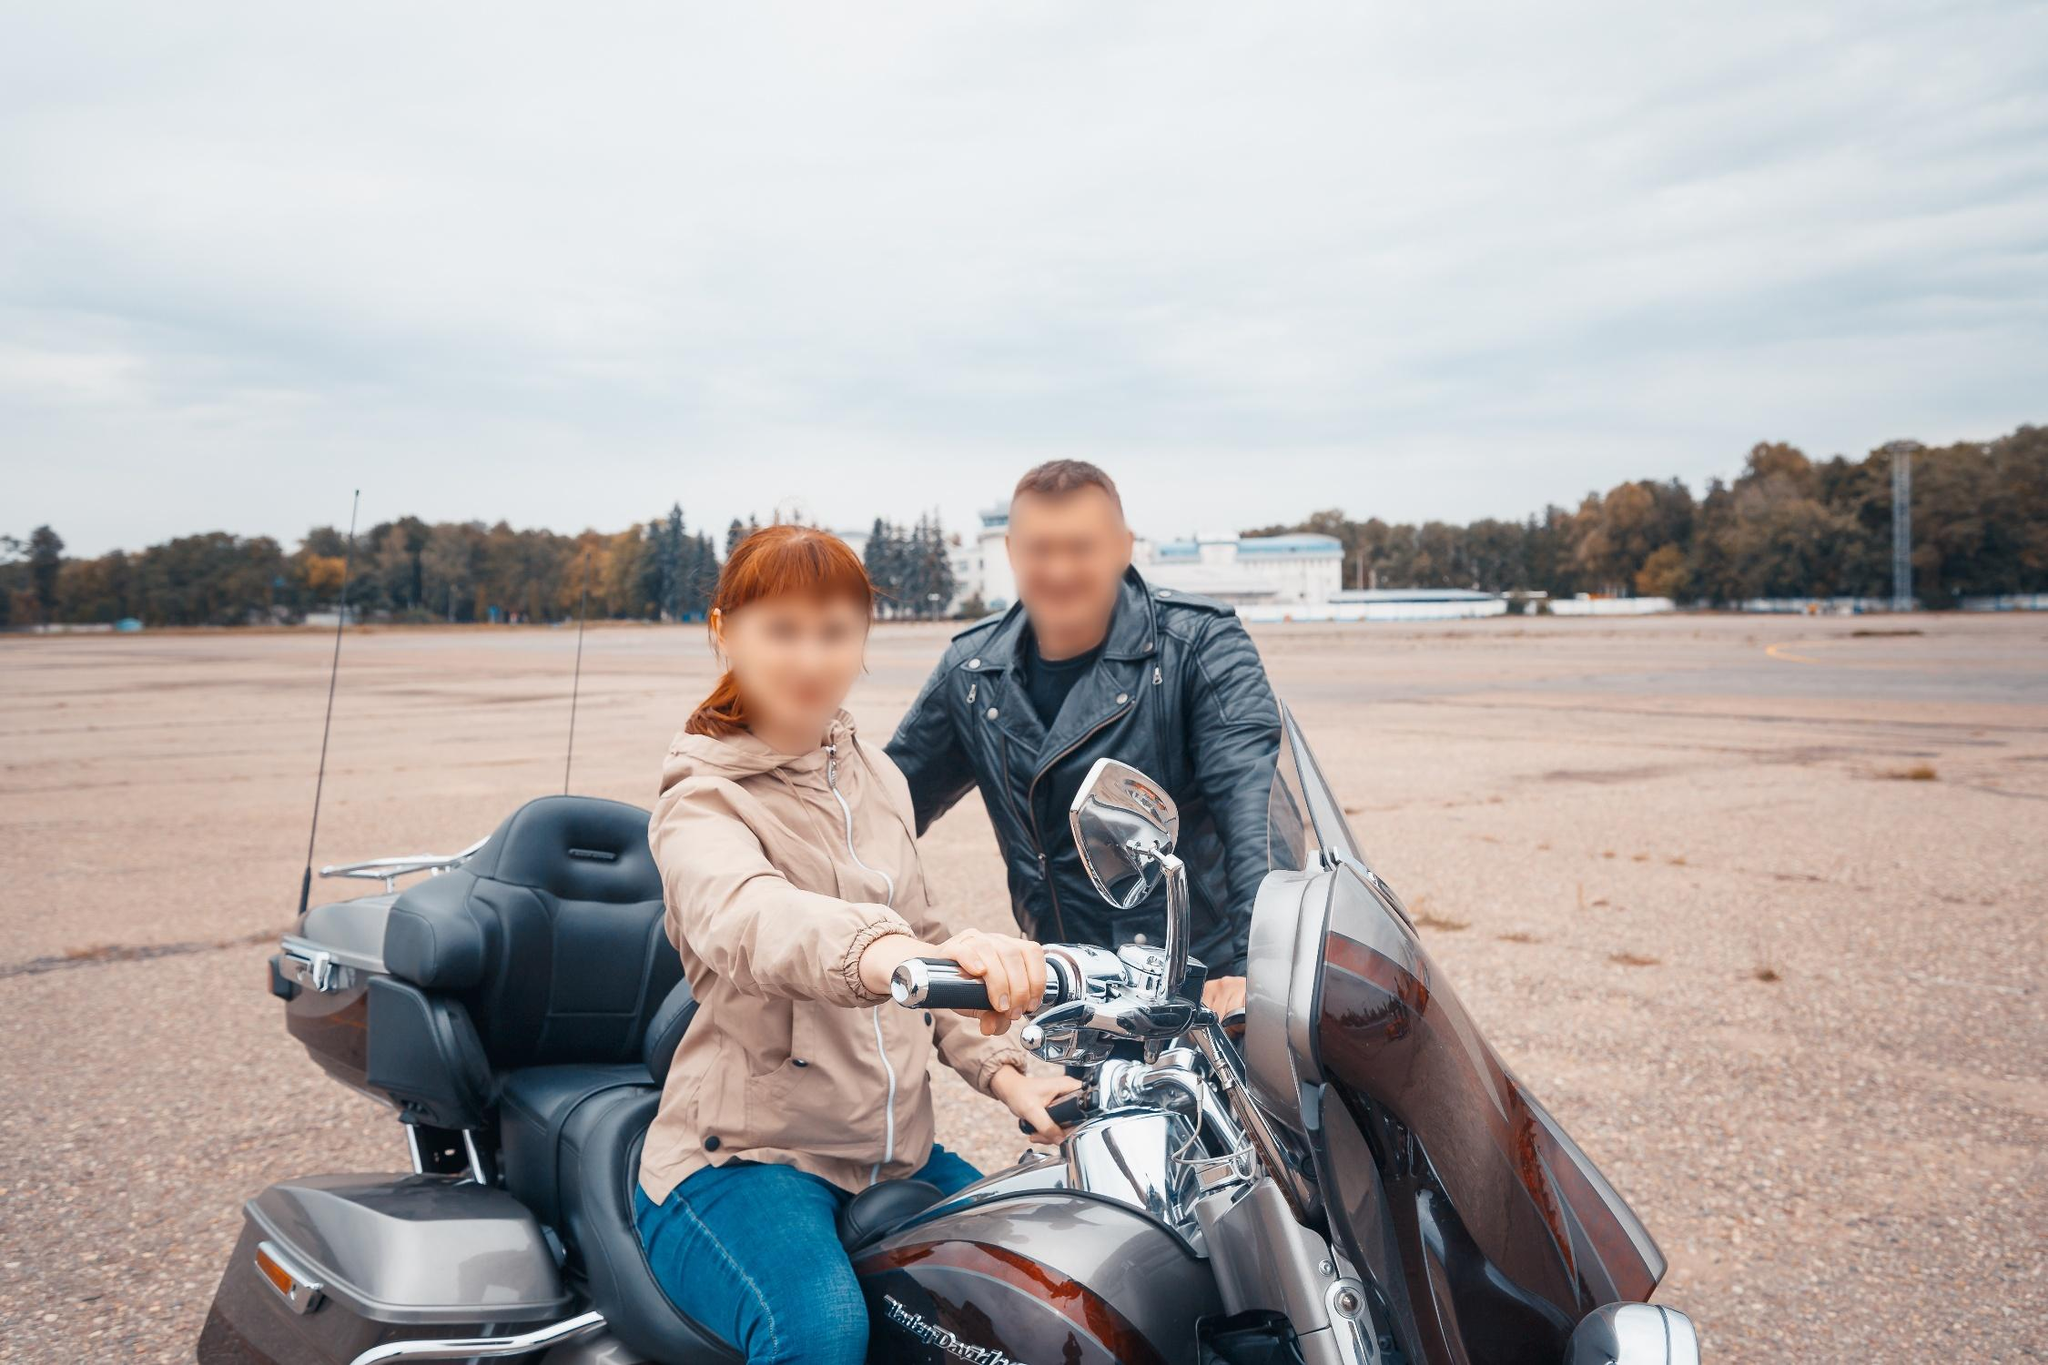Could you describe the location where the motorcycle is parked? The motorcycle is parked in a spacious, open area that appears to be an expansive gravel or paved lot. In the distance, a line of trees creates a natural boundary, hinting at a park or a remote location away from urban settings. The overcast sky above adds a subdued, peaceful mood to the scene. This setting could be a quiet airstrip or an industrial area devoid of activity, amplifying the sense of solitude and tranquility. 